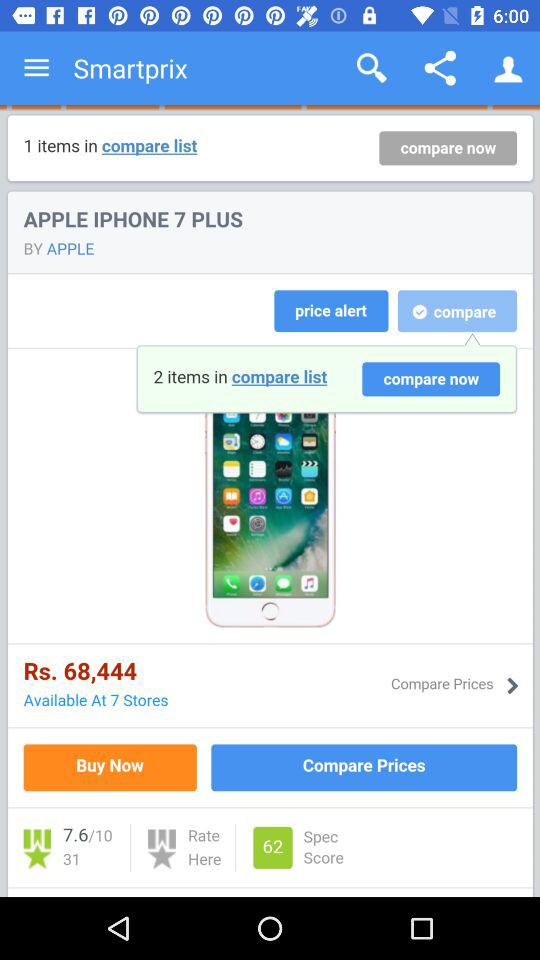What is the name of the item? The name of the item is "APPLE IPHONE 7 PLUS". 